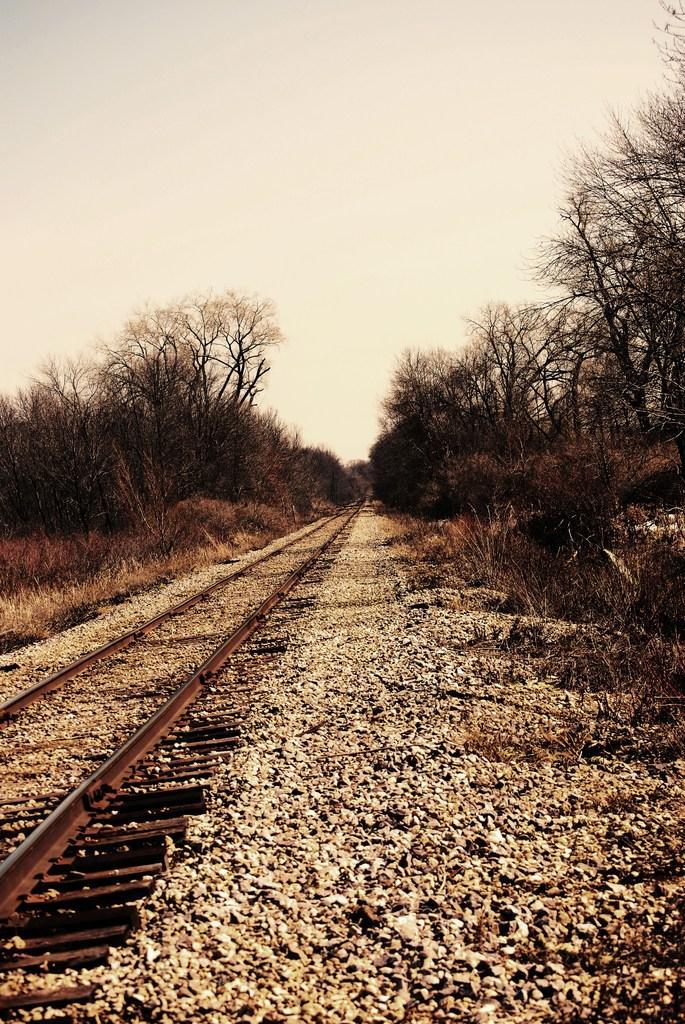Please provide a concise description of this image. Here, we can see a railway track and there are some trees, at the top there is a sky. 